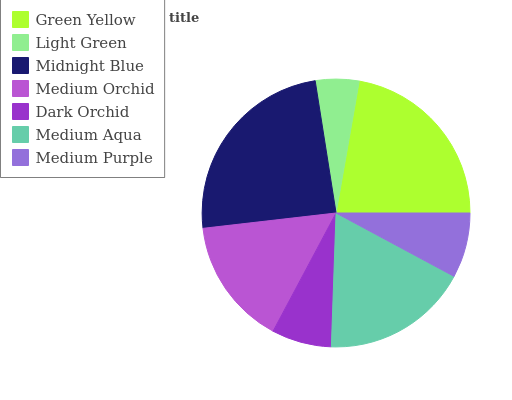Is Light Green the minimum?
Answer yes or no. Yes. Is Midnight Blue the maximum?
Answer yes or no. Yes. Is Midnight Blue the minimum?
Answer yes or no. No. Is Light Green the maximum?
Answer yes or no. No. Is Midnight Blue greater than Light Green?
Answer yes or no. Yes. Is Light Green less than Midnight Blue?
Answer yes or no. Yes. Is Light Green greater than Midnight Blue?
Answer yes or no. No. Is Midnight Blue less than Light Green?
Answer yes or no. No. Is Medium Orchid the high median?
Answer yes or no. Yes. Is Medium Orchid the low median?
Answer yes or no. Yes. Is Green Yellow the high median?
Answer yes or no. No. Is Light Green the low median?
Answer yes or no. No. 